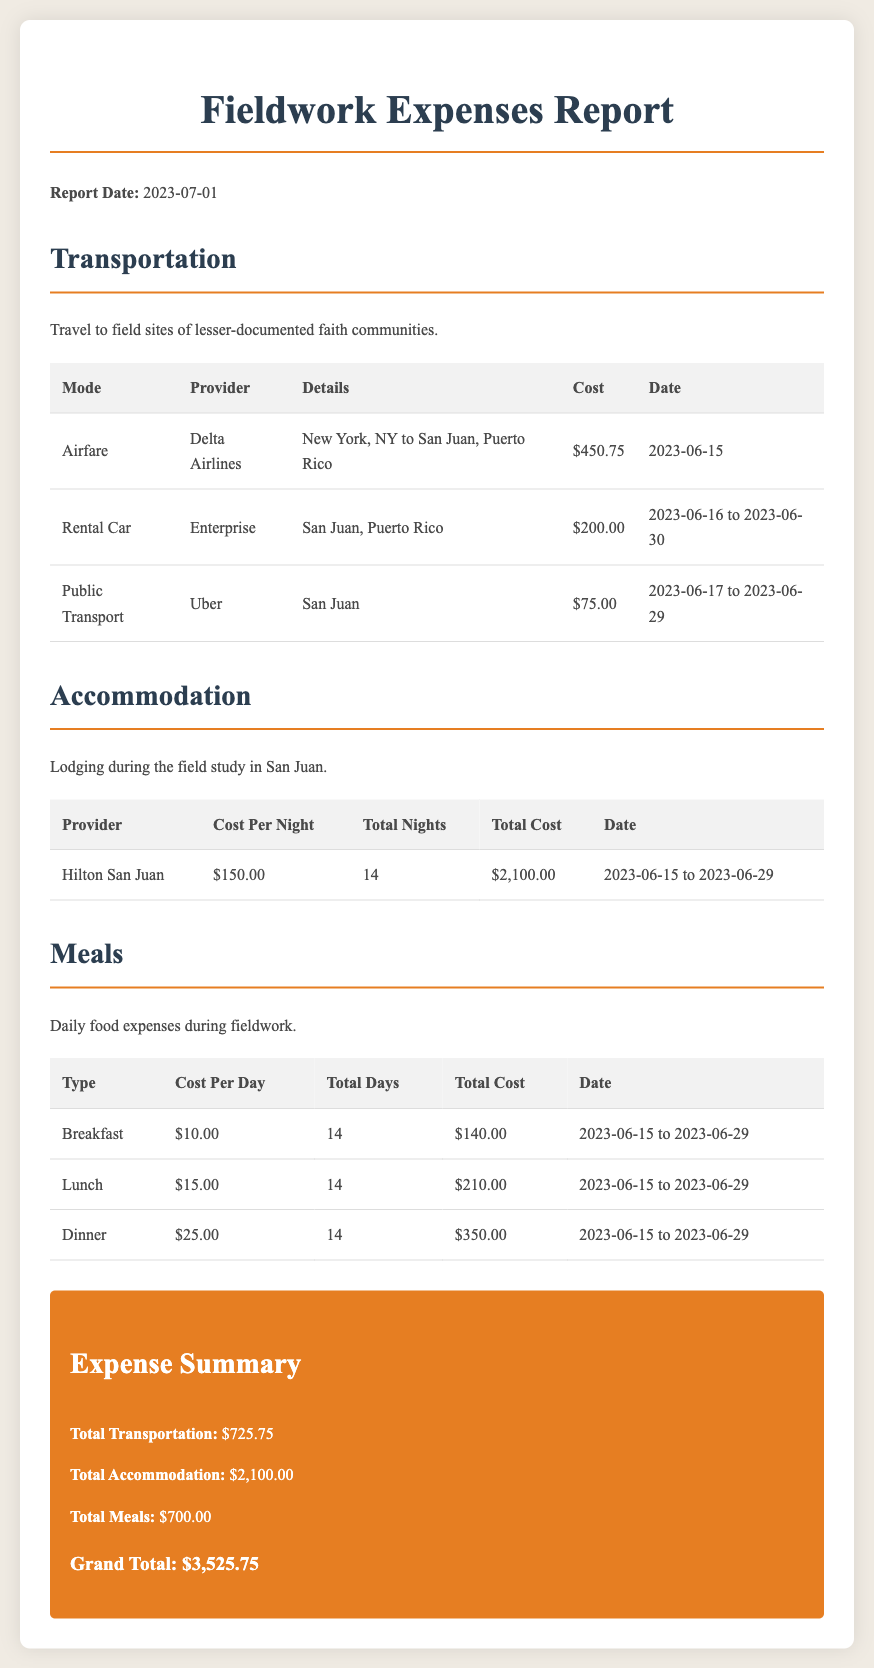What is the total cost of transportation? The total transportation cost is found in the summary section of the document, which sums up individual transportation expenses.
Answer: $725.75 Who provided the airfare for the trip? The airfare is listed under the transportation section of the report, specifying the provider's name.
Answer: Delta Airlines What was the cost of one night at the Hilton San Juan? The cost per night for accommodation is detailed in the accommodation section of the document.
Answer: $150.00 How many total days of meals are accounted for in the report? The total days of meals are calculated based on the duration of the fieldwork as indicated in the meals section.
Answer: 14 What is the grand total of all expenses? The grand total incorporates all transportation, accommodation, and meal costs, summarized at the end of the document.
Answer: $3,525.75 What type of transportation was rented in Puerto Rico? The types of transportation are detailed in the transportation section, specifying the mode used for travel.
Answer: Rental Car What was the total cost for dinner during the fieldwork? The total cost for dinner is indicated in the meals section, calculated based on the daily cost multiplied by the total days.
Answer: $350.00 How many nights did the field study last? The number of nights can be inferred from the accommodation details where total nights are listed.
Answer: 14 What mode of public transport was used in San Juan? The mode of transport is mentioned in the transportation section, giving specifics about public transport usage.
Answer: Uber 